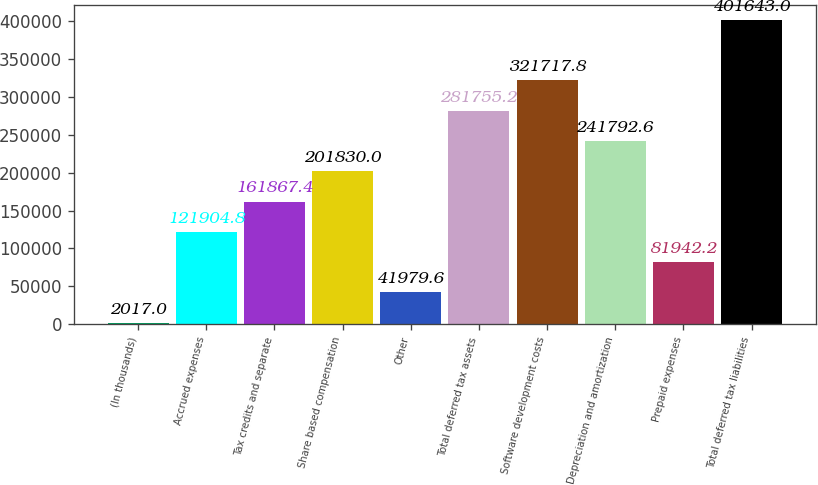Convert chart to OTSL. <chart><loc_0><loc_0><loc_500><loc_500><bar_chart><fcel>(In thousands)<fcel>Accrued expenses<fcel>Tax credits and separate<fcel>Share based compensation<fcel>Other<fcel>Total deferred tax assets<fcel>Software development costs<fcel>Depreciation and amortization<fcel>Prepaid expenses<fcel>Total deferred tax liabilities<nl><fcel>2017<fcel>121905<fcel>161867<fcel>201830<fcel>41979.6<fcel>281755<fcel>321718<fcel>241793<fcel>81942.2<fcel>401643<nl></chart> 